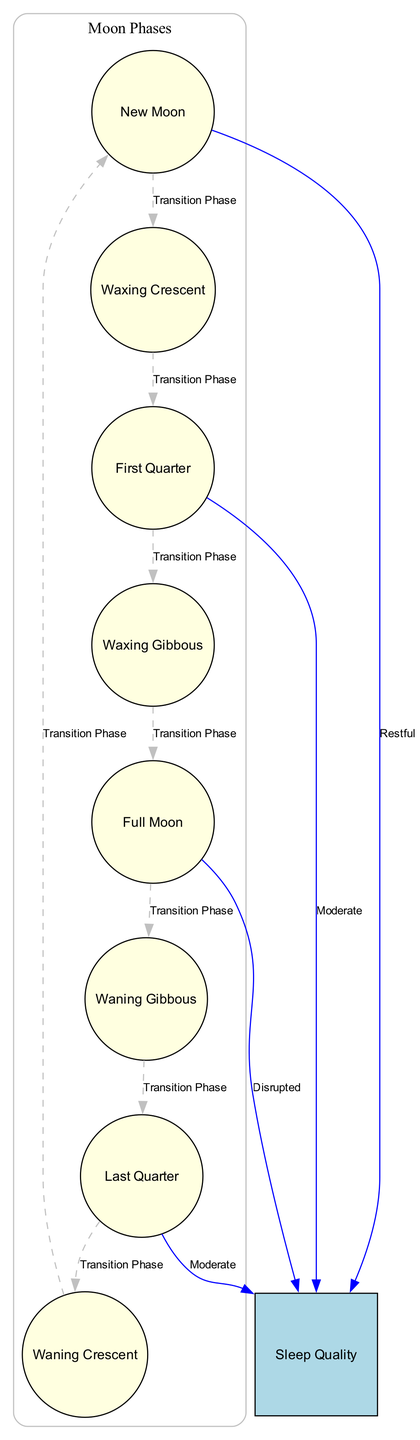What is the label of the node that represents the phase with no visible moon? The node that represents the phase with no visible moon is labeled "New Moon." This can be identified by looking for the node that describes the moon's position between Earth and the Sun, which defines this phase.
Answer: New Moon How many phases of the moon are depicted in the diagram? The diagram includes a total of eight phases of the moon. This is determined by counting all the nodes that represent each distinct lunar phase labeled from "New Moon" to "Waning Crescent."
Answer: 8 What transition phase occurs after the Waxing Crescent? The edge pointing from the "Waxing Crescent" node leads to the "First Quarter" node, indicating the transition phase that occurs next after Waxing Crescent.
Answer: First Quarter Which moon phase is associated with disrupted sleep quality? The "Full Moon" is the phase associated with disrupted sleep quality, as indicated by the direct edge from the "Full Moon" node to the "Sleep Quality" node, which is labeled as "Disrupted."
Answer: Full Moon What is the transition phase from First Quarter to the next moon phase? The transition phase from "First Quarter" to the next moon phase is "Waxing Gibbous." This is identified by following the directed edge leading from "First Quarter" to "Waxing Gibbous."
Answer: Waxing Gibbous During which moon phase is sleep quality described as restful? The "New Moon" phase is associated with restful sleep quality, as indicated by the connection from the "New Moon" node to the "Sleep Quality" node, labeled "Restful."
Answer: New Moon What are the two moon phases linked to moderate sleep quality? The two moon phases leading to moderate sleep quality are "First Quarter" and "Last Quarter," as shown by their respective connections to the "Sleep Quality" node, both labeled "Moderate."
Answer: First Quarter, Last Quarter Which phase has more than half of the moon illuminated and is decreasing in illumination? The phase that has more than half of the moon illuminated and is decreasing in illumination is "Waning Gibbous," as described in the node's definition and also represented in the diagram.
Answer: Waning Gibbous 